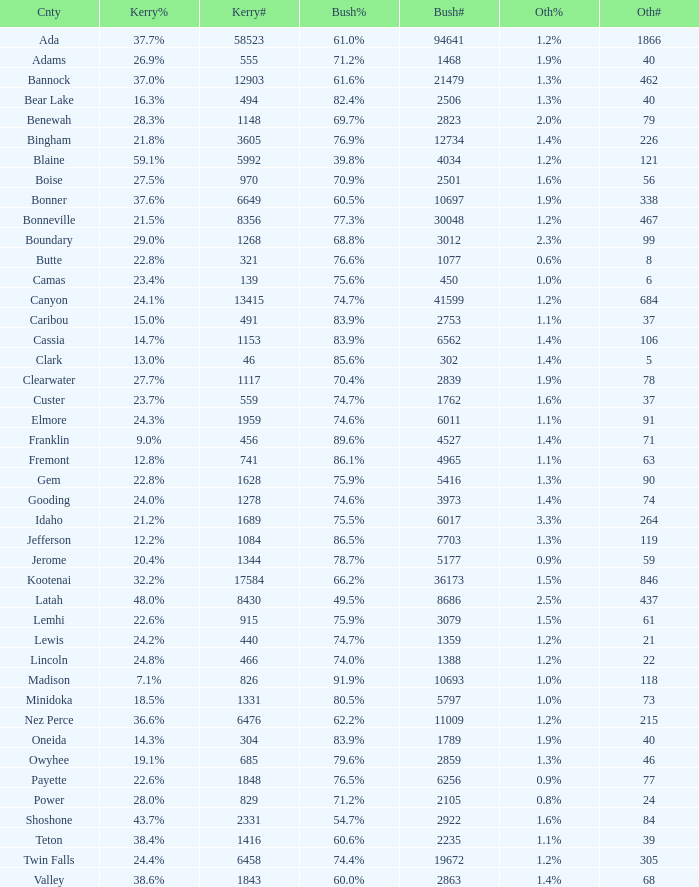How many people voted for Kerry in the county where 8 voted for others? 321.0. 